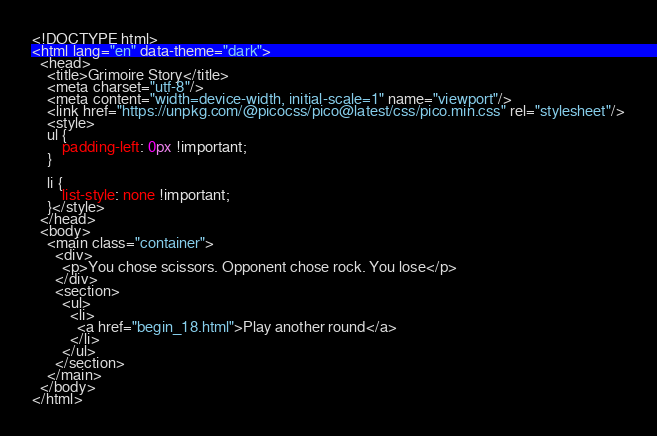Convert code to text. <code><loc_0><loc_0><loc_500><loc_500><_HTML_><!DOCTYPE html>
<html lang="en" data-theme="dark">
  <head>
    <title>Grimoire Story</title>
    <meta charset="utf-8"/>
    <meta content="width=device-width, initial-scale=1" name="viewport"/>
    <link href="https://unpkg.com/@picocss/pico@latest/css/pico.min.css" rel="stylesheet"/>
    <style>
    ul {
        padding-left: 0px !important;
    }

    li {
        list-style: none !important;
    }</style>
  </head>
  <body>
    <main class="container">
      <div>
        <p>You chose scissors. Opponent chose rock. You lose</p>
      </div>
      <section>
        <ul>
          <li>
            <a href="begin_18.html">Play another round</a>
          </li>
        </ul>
      </section>
    </main>
  </body>
</html></code> 